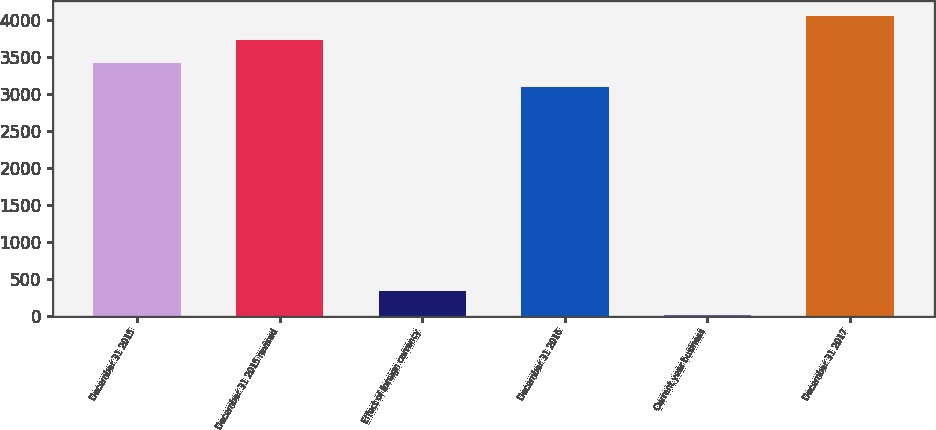Convert chart. <chart><loc_0><loc_0><loc_500><loc_500><bar_chart><fcel>December 31 2015<fcel>December 31 2015 revised<fcel>Effect of foreign currency<fcel>December 31 2016<fcel>Current year business<fcel>December 31 2017<nl><fcel>3413.16<fcel>3732.72<fcel>327.66<fcel>3093.6<fcel>8.1<fcel>4052.28<nl></chart> 